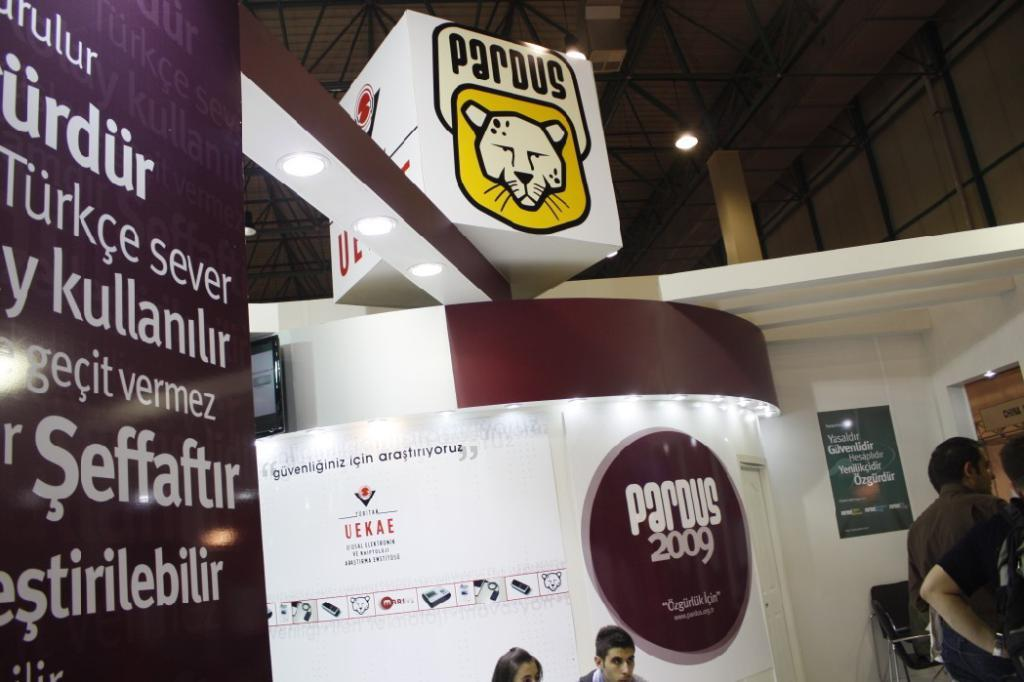<image>
Summarize the visual content of the image. A stand which has the word Parous on the top and a picture of a cat. 